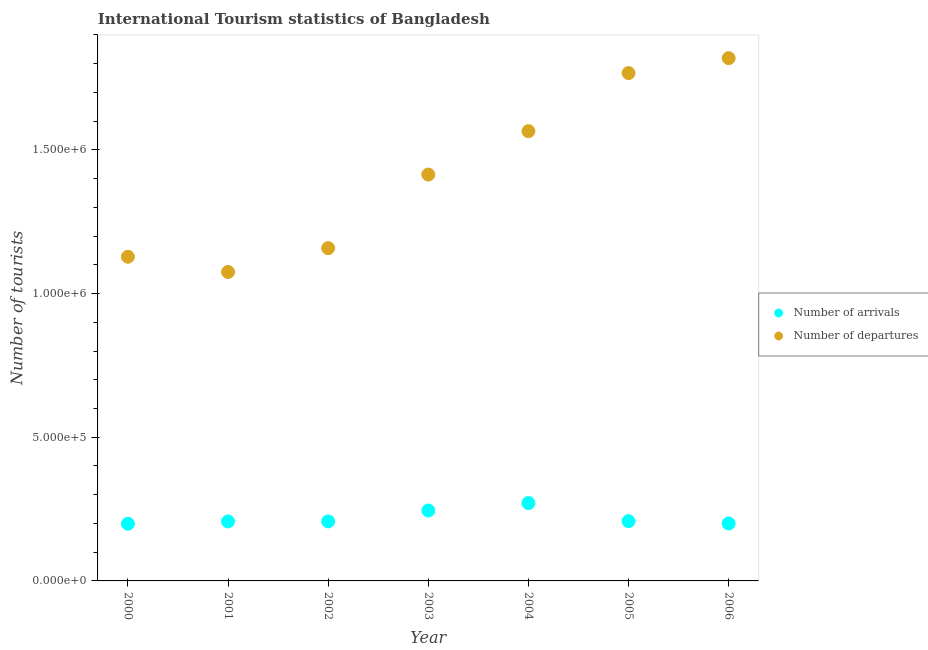How many different coloured dotlines are there?
Ensure brevity in your answer.  2. What is the number of tourist departures in 2003?
Offer a terse response. 1.41e+06. Across all years, what is the maximum number of tourist arrivals?
Give a very brief answer. 2.71e+05. Across all years, what is the minimum number of tourist arrivals?
Your response must be concise. 1.99e+05. In which year was the number of tourist arrivals minimum?
Make the answer very short. 2000. What is the total number of tourist departures in the graph?
Your answer should be compact. 9.93e+06. What is the difference between the number of tourist departures in 2000 and that in 2002?
Your answer should be compact. -3.00e+04. What is the difference between the number of tourist arrivals in 2001 and the number of tourist departures in 2006?
Keep it short and to the point. -1.61e+06. What is the average number of tourist arrivals per year?
Your answer should be compact. 2.20e+05. In the year 2002, what is the difference between the number of tourist departures and number of tourist arrivals?
Offer a terse response. 9.51e+05. What is the ratio of the number of tourist departures in 2001 to that in 2003?
Your answer should be compact. 0.76. What is the difference between the highest and the second highest number of tourist arrivals?
Provide a short and direct response. 2.60e+04. What is the difference between the highest and the lowest number of tourist departures?
Your response must be concise. 7.44e+05. How many dotlines are there?
Your response must be concise. 2. Does the graph contain any zero values?
Make the answer very short. No. Does the graph contain grids?
Keep it short and to the point. No. How many legend labels are there?
Make the answer very short. 2. How are the legend labels stacked?
Keep it short and to the point. Vertical. What is the title of the graph?
Your response must be concise. International Tourism statistics of Bangladesh. What is the label or title of the X-axis?
Your answer should be very brief. Year. What is the label or title of the Y-axis?
Your answer should be very brief. Number of tourists. What is the Number of tourists of Number of arrivals in 2000?
Offer a very short reply. 1.99e+05. What is the Number of tourists in Number of departures in 2000?
Provide a short and direct response. 1.13e+06. What is the Number of tourists of Number of arrivals in 2001?
Your answer should be very brief. 2.07e+05. What is the Number of tourists in Number of departures in 2001?
Provide a short and direct response. 1.08e+06. What is the Number of tourists of Number of arrivals in 2002?
Give a very brief answer. 2.07e+05. What is the Number of tourists in Number of departures in 2002?
Make the answer very short. 1.16e+06. What is the Number of tourists of Number of arrivals in 2003?
Offer a very short reply. 2.45e+05. What is the Number of tourists of Number of departures in 2003?
Provide a short and direct response. 1.41e+06. What is the Number of tourists of Number of arrivals in 2004?
Your answer should be compact. 2.71e+05. What is the Number of tourists in Number of departures in 2004?
Make the answer very short. 1.56e+06. What is the Number of tourists in Number of arrivals in 2005?
Give a very brief answer. 2.08e+05. What is the Number of tourists in Number of departures in 2005?
Make the answer very short. 1.77e+06. What is the Number of tourists of Number of departures in 2006?
Give a very brief answer. 1.82e+06. Across all years, what is the maximum Number of tourists of Number of arrivals?
Your response must be concise. 2.71e+05. Across all years, what is the maximum Number of tourists in Number of departures?
Keep it short and to the point. 1.82e+06. Across all years, what is the minimum Number of tourists of Number of arrivals?
Offer a very short reply. 1.99e+05. Across all years, what is the minimum Number of tourists of Number of departures?
Provide a succinct answer. 1.08e+06. What is the total Number of tourists of Number of arrivals in the graph?
Your answer should be compact. 1.54e+06. What is the total Number of tourists in Number of departures in the graph?
Offer a terse response. 9.93e+06. What is the difference between the Number of tourists in Number of arrivals in 2000 and that in 2001?
Your response must be concise. -8000. What is the difference between the Number of tourists in Number of departures in 2000 and that in 2001?
Your answer should be compact. 5.30e+04. What is the difference between the Number of tourists in Number of arrivals in 2000 and that in 2002?
Keep it short and to the point. -8000. What is the difference between the Number of tourists in Number of departures in 2000 and that in 2002?
Make the answer very short. -3.00e+04. What is the difference between the Number of tourists of Number of arrivals in 2000 and that in 2003?
Your answer should be compact. -4.60e+04. What is the difference between the Number of tourists in Number of departures in 2000 and that in 2003?
Provide a short and direct response. -2.86e+05. What is the difference between the Number of tourists in Number of arrivals in 2000 and that in 2004?
Make the answer very short. -7.20e+04. What is the difference between the Number of tourists of Number of departures in 2000 and that in 2004?
Offer a terse response. -4.37e+05. What is the difference between the Number of tourists of Number of arrivals in 2000 and that in 2005?
Offer a terse response. -9000. What is the difference between the Number of tourists in Number of departures in 2000 and that in 2005?
Offer a terse response. -6.39e+05. What is the difference between the Number of tourists in Number of arrivals in 2000 and that in 2006?
Keep it short and to the point. -1000. What is the difference between the Number of tourists in Number of departures in 2000 and that in 2006?
Provide a succinct answer. -6.91e+05. What is the difference between the Number of tourists in Number of arrivals in 2001 and that in 2002?
Offer a very short reply. 0. What is the difference between the Number of tourists of Number of departures in 2001 and that in 2002?
Keep it short and to the point. -8.30e+04. What is the difference between the Number of tourists of Number of arrivals in 2001 and that in 2003?
Ensure brevity in your answer.  -3.80e+04. What is the difference between the Number of tourists in Number of departures in 2001 and that in 2003?
Your response must be concise. -3.39e+05. What is the difference between the Number of tourists in Number of arrivals in 2001 and that in 2004?
Provide a short and direct response. -6.40e+04. What is the difference between the Number of tourists of Number of departures in 2001 and that in 2004?
Offer a terse response. -4.90e+05. What is the difference between the Number of tourists in Number of arrivals in 2001 and that in 2005?
Your answer should be very brief. -1000. What is the difference between the Number of tourists in Number of departures in 2001 and that in 2005?
Ensure brevity in your answer.  -6.92e+05. What is the difference between the Number of tourists of Number of arrivals in 2001 and that in 2006?
Your answer should be very brief. 7000. What is the difference between the Number of tourists of Number of departures in 2001 and that in 2006?
Offer a terse response. -7.44e+05. What is the difference between the Number of tourists in Number of arrivals in 2002 and that in 2003?
Offer a very short reply. -3.80e+04. What is the difference between the Number of tourists of Number of departures in 2002 and that in 2003?
Give a very brief answer. -2.56e+05. What is the difference between the Number of tourists in Number of arrivals in 2002 and that in 2004?
Offer a very short reply. -6.40e+04. What is the difference between the Number of tourists of Number of departures in 2002 and that in 2004?
Offer a very short reply. -4.07e+05. What is the difference between the Number of tourists in Number of arrivals in 2002 and that in 2005?
Offer a very short reply. -1000. What is the difference between the Number of tourists of Number of departures in 2002 and that in 2005?
Offer a very short reply. -6.09e+05. What is the difference between the Number of tourists in Number of arrivals in 2002 and that in 2006?
Keep it short and to the point. 7000. What is the difference between the Number of tourists in Number of departures in 2002 and that in 2006?
Give a very brief answer. -6.61e+05. What is the difference between the Number of tourists of Number of arrivals in 2003 and that in 2004?
Your answer should be very brief. -2.60e+04. What is the difference between the Number of tourists of Number of departures in 2003 and that in 2004?
Keep it short and to the point. -1.51e+05. What is the difference between the Number of tourists in Number of arrivals in 2003 and that in 2005?
Keep it short and to the point. 3.70e+04. What is the difference between the Number of tourists of Number of departures in 2003 and that in 2005?
Your response must be concise. -3.53e+05. What is the difference between the Number of tourists of Number of arrivals in 2003 and that in 2006?
Your answer should be compact. 4.50e+04. What is the difference between the Number of tourists in Number of departures in 2003 and that in 2006?
Give a very brief answer. -4.05e+05. What is the difference between the Number of tourists of Number of arrivals in 2004 and that in 2005?
Your answer should be very brief. 6.30e+04. What is the difference between the Number of tourists in Number of departures in 2004 and that in 2005?
Your answer should be compact. -2.02e+05. What is the difference between the Number of tourists in Number of arrivals in 2004 and that in 2006?
Your answer should be very brief. 7.10e+04. What is the difference between the Number of tourists in Number of departures in 2004 and that in 2006?
Offer a terse response. -2.54e+05. What is the difference between the Number of tourists in Number of arrivals in 2005 and that in 2006?
Your answer should be compact. 8000. What is the difference between the Number of tourists in Number of departures in 2005 and that in 2006?
Offer a terse response. -5.20e+04. What is the difference between the Number of tourists of Number of arrivals in 2000 and the Number of tourists of Number of departures in 2001?
Provide a short and direct response. -8.76e+05. What is the difference between the Number of tourists of Number of arrivals in 2000 and the Number of tourists of Number of departures in 2002?
Offer a terse response. -9.59e+05. What is the difference between the Number of tourists in Number of arrivals in 2000 and the Number of tourists in Number of departures in 2003?
Provide a succinct answer. -1.22e+06. What is the difference between the Number of tourists of Number of arrivals in 2000 and the Number of tourists of Number of departures in 2004?
Ensure brevity in your answer.  -1.37e+06. What is the difference between the Number of tourists in Number of arrivals in 2000 and the Number of tourists in Number of departures in 2005?
Keep it short and to the point. -1.57e+06. What is the difference between the Number of tourists in Number of arrivals in 2000 and the Number of tourists in Number of departures in 2006?
Give a very brief answer. -1.62e+06. What is the difference between the Number of tourists of Number of arrivals in 2001 and the Number of tourists of Number of departures in 2002?
Your response must be concise. -9.51e+05. What is the difference between the Number of tourists in Number of arrivals in 2001 and the Number of tourists in Number of departures in 2003?
Offer a very short reply. -1.21e+06. What is the difference between the Number of tourists in Number of arrivals in 2001 and the Number of tourists in Number of departures in 2004?
Give a very brief answer. -1.36e+06. What is the difference between the Number of tourists of Number of arrivals in 2001 and the Number of tourists of Number of departures in 2005?
Your answer should be compact. -1.56e+06. What is the difference between the Number of tourists in Number of arrivals in 2001 and the Number of tourists in Number of departures in 2006?
Your answer should be compact. -1.61e+06. What is the difference between the Number of tourists in Number of arrivals in 2002 and the Number of tourists in Number of departures in 2003?
Offer a terse response. -1.21e+06. What is the difference between the Number of tourists of Number of arrivals in 2002 and the Number of tourists of Number of departures in 2004?
Give a very brief answer. -1.36e+06. What is the difference between the Number of tourists in Number of arrivals in 2002 and the Number of tourists in Number of departures in 2005?
Offer a very short reply. -1.56e+06. What is the difference between the Number of tourists in Number of arrivals in 2002 and the Number of tourists in Number of departures in 2006?
Ensure brevity in your answer.  -1.61e+06. What is the difference between the Number of tourists in Number of arrivals in 2003 and the Number of tourists in Number of departures in 2004?
Your answer should be compact. -1.32e+06. What is the difference between the Number of tourists in Number of arrivals in 2003 and the Number of tourists in Number of departures in 2005?
Provide a succinct answer. -1.52e+06. What is the difference between the Number of tourists in Number of arrivals in 2003 and the Number of tourists in Number of departures in 2006?
Offer a terse response. -1.57e+06. What is the difference between the Number of tourists in Number of arrivals in 2004 and the Number of tourists in Number of departures in 2005?
Offer a very short reply. -1.50e+06. What is the difference between the Number of tourists in Number of arrivals in 2004 and the Number of tourists in Number of departures in 2006?
Ensure brevity in your answer.  -1.55e+06. What is the difference between the Number of tourists in Number of arrivals in 2005 and the Number of tourists in Number of departures in 2006?
Your answer should be compact. -1.61e+06. What is the average Number of tourists of Number of arrivals per year?
Offer a terse response. 2.20e+05. What is the average Number of tourists in Number of departures per year?
Offer a terse response. 1.42e+06. In the year 2000, what is the difference between the Number of tourists in Number of arrivals and Number of tourists in Number of departures?
Your answer should be very brief. -9.29e+05. In the year 2001, what is the difference between the Number of tourists of Number of arrivals and Number of tourists of Number of departures?
Make the answer very short. -8.68e+05. In the year 2002, what is the difference between the Number of tourists of Number of arrivals and Number of tourists of Number of departures?
Provide a short and direct response. -9.51e+05. In the year 2003, what is the difference between the Number of tourists in Number of arrivals and Number of tourists in Number of departures?
Your answer should be very brief. -1.17e+06. In the year 2004, what is the difference between the Number of tourists of Number of arrivals and Number of tourists of Number of departures?
Provide a short and direct response. -1.29e+06. In the year 2005, what is the difference between the Number of tourists in Number of arrivals and Number of tourists in Number of departures?
Make the answer very short. -1.56e+06. In the year 2006, what is the difference between the Number of tourists of Number of arrivals and Number of tourists of Number of departures?
Provide a short and direct response. -1.62e+06. What is the ratio of the Number of tourists of Number of arrivals in 2000 to that in 2001?
Keep it short and to the point. 0.96. What is the ratio of the Number of tourists in Number of departures in 2000 to that in 2001?
Offer a terse response. 1.05. What is the ratio of the Number of tourists of Number of arrivals in 2000 to that in 2002?
Keep it short and to the point. 0.96. What is the ratio of the Number of tourists in Number of departures in 2000 to that in 2002?
Provide a short and direct response. 0.97. What is the ratio of the Number of tourists of Number of arrivals in 2000 to that in 2003?
Provide a short and direct response. 0.81. What is the ratio of the Number of tourists in Number of departures in 2000 to that in 2003?
Give a very brief answer. 0.8. What is the ratio of the Number of tourists of Number of arrivals in 2000 to that in 2004?
Provide a short and direct response. 0.73. What is the ratio of the Number of tourists in Number of departures in 2000 to that in 2004?
Ensure brevity in your answer.  0.72. What is the ratio of the Number of tourists in Number of arrivals in 2000 to that in 2005?
Keep it short and to the point. 0.96. What is the ratio of the Number of tourists in Number of departures in 2000 to that in 2005?
Give a very brief answer. 0.64. What is the ratio of the Number of tourists in Number of arrivals in 2000 to that in 2006?
Keep it short and to the point. 0.99. What is the ratio of the Number of tourists of Number of departures in 2000 to that in 2006?
Ensure brevity in your answer.  0.62. What is the ratio of the Number of tourists in Number of departures in 2001 to that in 2002?
Ensure brevity in your answer.  0.93. What is the ratio of the Number of tourists in Number of arrivals in 2001 to that in 2003?
Your response must be concise. 0.84. What is the ratio of the Number of tourists in Number of departures in 2001 to that in 2003?
Give a very brief answer. 0.76. What is the ratio of the Number of tourists in Number of arrivals in 2001 to that in 2004?
Your response must be concise. 0.76. What is the ratio of the Number of tourists in Number of departures in 2001 to that in 2004?
Your answer should be compact. 0.69. What is the ratio of the Number of tourists of Number of arrivals in 2001 to that in 2005?
Provide a succinct answer. 1. What is the ratio of the Number of tourists in Number of departures in 2001 to that in 2005?
Provide a short and direct response. 0.61. What is the ratio of the Number of tourists of Number of arrivals in 2001 to that in 2006?
Ensure brevity in your answer.  1.03. What is the ratio of the Number of tourists in Number of departures in 2001 to that in 2006?
Your answer should be very brief. 0.59. What is the ratio of the Number of tourists in Number of arrivals in 2002 to that in 2003?
Make the answer very short. 0.84. What is the ratio of the Number of tourists of Number of departures in 2002 to that in 2003?
Your answer should be compact. 0.82. What is the ratio of the Number of tourists in Number of arrivals in 2002 to that in 2004?
Give a very brief answer. 0.76. What is the ratio of the Number of tourists in Number of departures in 2002 to that in 2004?
Offer a very short reply. 0.74. What is the ratio of the Number of tourists in Number of departures in 2002 to that in 2005?
Offer a terse response. 0.66. What is the ratio of the Number of tourists of Number of arrivals in 2002 to that in 2006?
Keep it short and to the point. 1.03. What is the ratio of the Number of tourists in Number of departures in 2002 to that in 2006?
Offer a very short reply. 0.64. What is the ratio of the Number of tourists in Number of arrivals in 2003 to that in 2004?
Offer a very short reply. 0.9. What is the ratio of the Number of tourists in Number of departures in 2003 to that in 2004?
Your response must be concise. 0.9. What is the ratio of the Number of tourists in Number of arrivals in 2003 to that in 2005?
Your response must be concise. 1.18. What is the ratio of the Number of tourists of Number of departures in 2003 to that in 2005?
Offer a very short reply. 0.8. What is the ratio of the Number of tourists of Number of arrivals in 2003 to that in 2006?
Give a very brief answer. 1.23. What is the ratio of the Number of tourists of Number of departures in 2003 to that in 2006?
Your response must be concise. 0.78. What is the ratio of the Number of tourists of Number of arrivals in 2004 to that in 2005?
Your answer should be very brief. 1.3. What is the ratio of the Number of tourists of Number of departures in 2004 to that in 2005?
Give a very brief answer. 0.89. What is the ratio of the Number of tourists in Number of arrivals in 2004 to that in 2006?
Offer a very short reply. 1.35. What is the ratio of the Number of tourists of Number of departures in 2004 to that in 2006?
Your answer should be compact. 0.86. What is the ratio of the Number of tourists of Number of arrivals in 2005 to that in 2006?
Offer a very short reply. 1.04. What is the ratio of the Number of tourists in Number of departures in 2005 to that in 2006?
Ensure brevity in your answer.  0.97. What is the difference between the highest and the second highest Number of tourists in Number of arrivals?
Your answer should be compact. 2.60e+04. What is the difference between the highest and the second highest Number of tourists of Number of departures?
Your answer should be very brief. 5.20e+04. What is the difference between the highest and the lowest Number of tourists in Number of arrivals?
Keep it short and to the point. 7.20e+04. What is the difference between the highest and the lowest Number of tourists in Number of departures?
Your answer should be compact. 7.44e+05. 